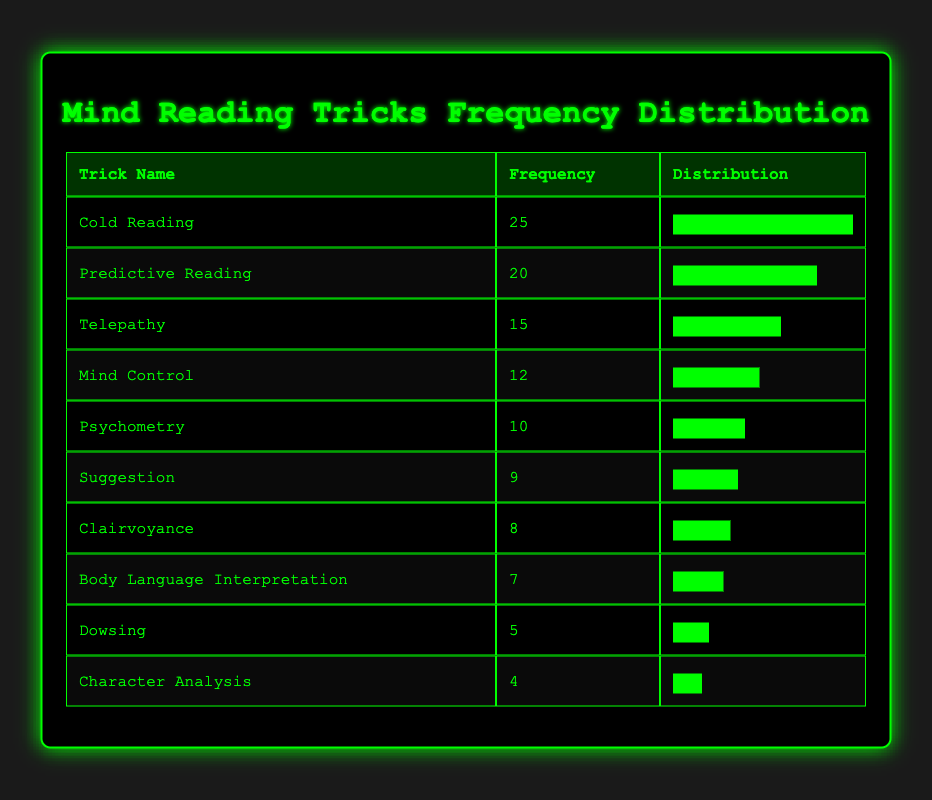What is the trick with the highest frequency used in performances? By looking at the frequency values in the table, "Cold Reading" has the highest frequency at 25.
Answer: Cold Reading How many tricks have a frequency greater than 10? "Cold Reading," "Predictive Reading," "Telepathy," and "Mind Control" each have frequencies that exceed 10. There are four tricks in total.
Answer: 4 What is the average frequency of all the mind-reading tricks? The total frequency of all tricks is 15 + 10 + 25 + 5 + 8 + 12 + 20 + 7 + 9 + 4 = 115. There are 10 tricks, so the average is 115/10 = 11.5.
Answer: 11.5 Is "Dowsing" among the top three most frequently used tricks? "Dowsing" has a frequency of 5. The top three tricks by frequency are "Cold Reading," "Predictive Reading," and "Telepathy," which have higher frequencies. Thus, it is not in the top three.
Answer: No What is the difference in frequency between the trick with the highest and lowest frequencies? "Cold Reading" has the highest frequency of 25, while "Character Analysis" has the lowest frequency of 4. The difference is 25 - 4 = 21.
Answer: 21 Which mind-reading trick has the second-highest frequency, and what is its frequency? The second-highest frequency is "Predictive Reading," which has a frequency of 20, following "Cold Reading."
Answer: Predictive Reading, 20 How many tricks use "Dowsing," "Clairvoyance," and "Character Analysis" together? The frequencies for these tricks are "Dowsing" 5, "Clairvoyance" 8, and "Character Analysis" 4. The total frequency when summed up is 5 + 8 + 4 = 17.
Answer: 17 Which trick has a frequency less than 10 and what is that frequency? The tricks with a frequency less than 10 are "Dowsing" (5), "Clairvoyance" (8), "Body Language Interpretation" (7), "Suggestion" (9), and "Character Analysis" (4). The trick with the lowest frequency below 10 is "Character Analysis," which has 4.
Answer: Character Analysis, 4 